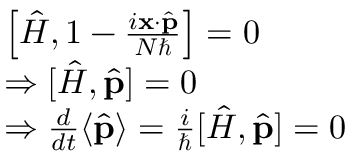<formula> <loc_0><loc_0><loc_500><loc_500>{ \begin{array} { r l } & { \left [ { \hat { H } } , 1 - { \frac { i x \cdot { \hat { p } } } { N } } \right ] = 0 } \\ & { \Rightarrow [ { \hat { H } } , { \hat { p } } ] = 0 } \\ & { \Rightarrow { \frac { d } { d t } } \langle { \hat { p } } \rangle = { \frac { i } { } } [ { \hat { H } } , { \hat { p } } ] = 0 } \end{array} }</formula> 